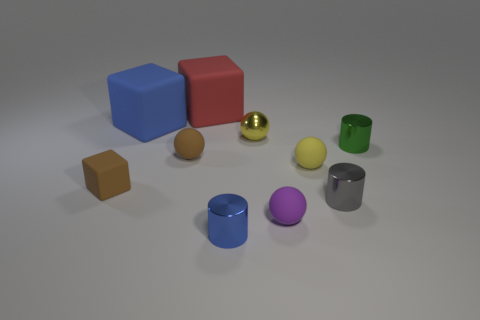What number of small matte things have the same color as the tiny block?
Give a very brief answer. 1. Is the color of the small cube the same as the rubber ball to the left of the small yellow metallic object?
Ensure brevity in your answer.  Yes. There is a large thing on the left side of the matte ball on the left side of the shiny cylinder in front of the gray metal cylinder; what is its material?
Offer a very short reply. Rubber. There is a small thing that is the same color as the small metallic ball; what is it made of?
Your answer should be compact. Rubber. How many objects are either small cyan blocks or cylinders?
Offer a very short reply. 3. Is the blue object that is in front of the tiny green shiny thing made of the same material as the small gray cylinder?
Give a very brief answer. Yes. What number of objects are gray shiny cylinders that are to the right of the big red rubber object or brown spheres?
Offer a terse response. 2. The small ball that is made of the same material as the blue cylinder is what color?
Your answer should be compact. Yellow. Is there a blue rubber sphere of the same size as the gray metal thing?
Ensure brevity in your answer.  No. There is a small rubber ball that is on the left side of the small blue thing; is it the same color as the tiny cube?
Ensure brevity in your answer.  Yes. 